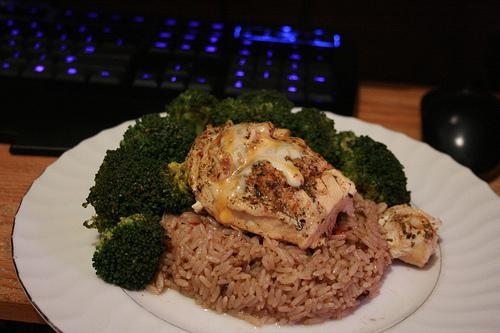Question: what shape is the plate?
Choices:
A. Square.
B. Round.
C. Rectangle.
D. Triangle.
Answer with the letter. Answer: B Question: what type of green vegetable?
Choices:
A. Spinach.
B. Lettuce.
C. Asparagus.
D. Broccoli.
Answer with the letter. Answer: D Question: how many different foods on the plate?
Choices:
A. Just one.
B. Two.
C. Three.
D. Five.
Answer with the letter. Answer: C Question: where is the rice?
Choices:
A. Above the chicken.
B. Under the chicken.
C. Beside the chicken.
D. There is none.
Answer with the letter. Answer: B 